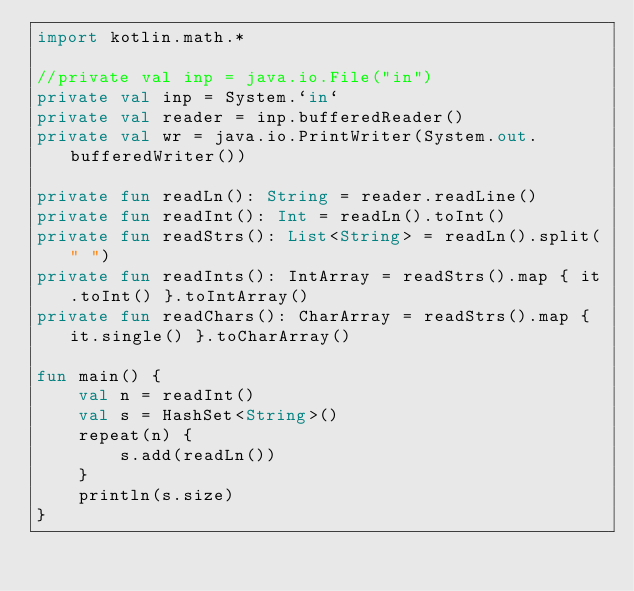Convert code to text. <code><loc_0><loc_0><loc_500><loc_500><_Kotlin_>import kotlin.math.*

//private val inp = java.io.File("in")
private val inp = System.`in`
private val reader = inp.bufferedReader()
private val wr = java.io.PrintWriter(System.out.bufferedWriter())

private fun readLn(): String = reader.readLine()
private fun readInt(): Int = readLn().toInt()
private fun readStrs(): List<String> = readLn().split(" ")
private fun readInts(): IntArray = readStrs().map { it.toInt() }.toIntArray()
private fun readChars(): CharArray = readStrs().map { it.single() }.toCharArray()

fun main() {
    val n = readInt()
    val s = HashSet<String>()
    repeat(n) {
        s.add(readLn())
    }
    println(s.size)
}</code> 